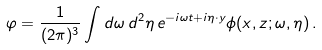<formula> <loc_0><loc_0><loc_500><loc_500>\varphi = \frac { 1 } { ( 2 \pi ) ^ { 3 } } \int d \omega \, d ^ { 2 } \eta \, e ^ { - i \omega t + i \eta \cdot { y } } \phi ( x , z ; \omega , \eta ) \, .</formula> 